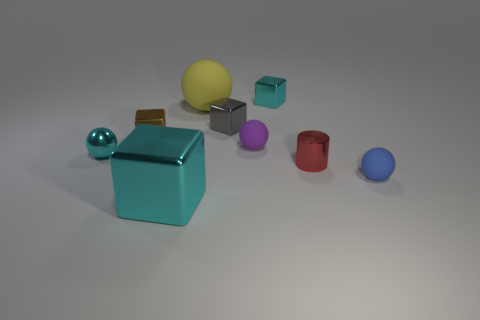Subtract all big cyan blocks. How many blocks are left? 3 Subtract all green cylinders. How many cyan blocks are left? 2 Subtract all brown blocks. How many blocks are left? 3 Add 1 yellow metallic blocks. How many objects exist? 10 Subtract 1 cubes. How many cubes are left? 3 Subtract all cylinders. How many objects are left? 8 Add 3 yellow objects. How many yellow objects are left? 4 Add 6 small red metal objects. How many small red metal objects exist? 7 Subtract 0 red blocks. How many objects are left? 9 Subtract all blue balls. Subtract all green blocks. How many balls are left? 3 